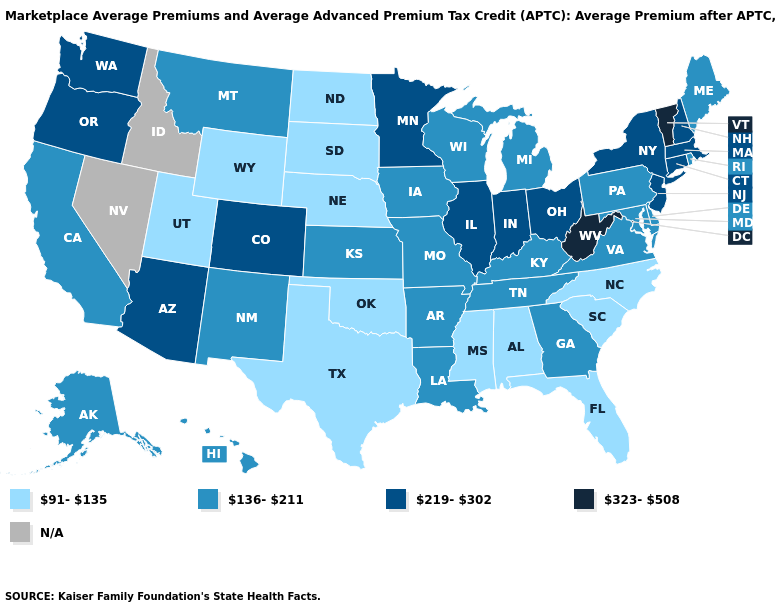Does Maine have the lowest value in the Northeast?
Quick response, please. Yes. Which states have the lowest value in the USA?
Concise answer only. Alabama, Florida, Mississippi, Nebraska, North Carolina, North Dakota, Oklahoma, South Carolina, South Dakota, Texas, Utah, Wyoming. Name the states that have a value in the range 91-135?
Keep it brief. Alabama, Florida, Mississippi, Nebraska, North Carolina, North Dakota, Oklahoma, South Carolina, South Dakota, Texas, Utah, Wyoming. Name the states that have a value in the range 323-508?
Answer briefly. Vermont, West Virginia. What is the lowest value in states that border Michigan?
Be succinct. 136-211. What is the value of Ohio?
Give a very brief answer. 219-302. Among the states that border Wyoming , which have the highest value?
Keep it brief. Colorado. Name the states that have a value in the range N/A?
Short answer required. Idaho, Nevada. Does Arkansas have the lowest value in the South?
Keep it brief. No. Name the states that have a value in the range 91-135?
Concise answer only. Alabama, Florida, Mississippi, Nebraska, North Carolina, North Dakota, Oklahoma, South Carolina, South Dakota, Texas, Utah, Wyoming. Name the states that have a value in the range N/A?
Answer briefly. Idaho, Nevada. Name the states that have a value in the range 136-211?
Write a very short answer. Alaska, Arkansas, California, Delaware, Georgia, Hawaii, Iowa, Kansas, Kentucky, Louisiana, Maine, Maryland, Michigan, Missouri, Montana, New Mexico, Pennsylvania, Rhode Island, Tennessee, Virginia, Wisconsin. Does Virginia have the highest value in the USA?
Write a very short answer. No. Does Indiana have the highest value in the MidWest?
Short answer required. Yes. Among the states that border South Carolina , which have the highest value?
Give a very brief answer. Georgia. 